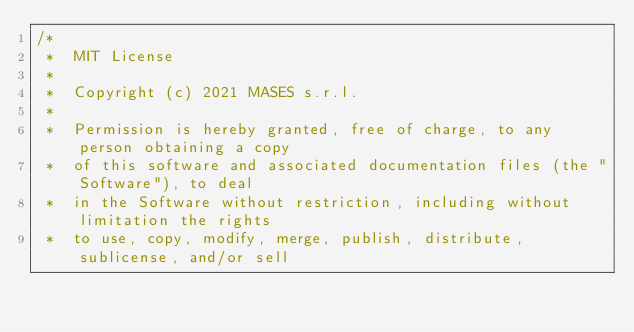<code> <loc_0><loc_0><loc_500><loc_500><_Java_>/*
 *  MIT License
 *
 *  Copyright (c) 2021 MASES s.r.l.
 *
 *  Permission is hereby granted, free of charge, to any person obtaining a copy
 *  of this software and associated documentation files (the "Software"), to deal
 *  in the Software without restriction, including without limitation the rights
 *  to use, copy, modify, merge, publish, distribute, sublicense, and/or sell</code> 